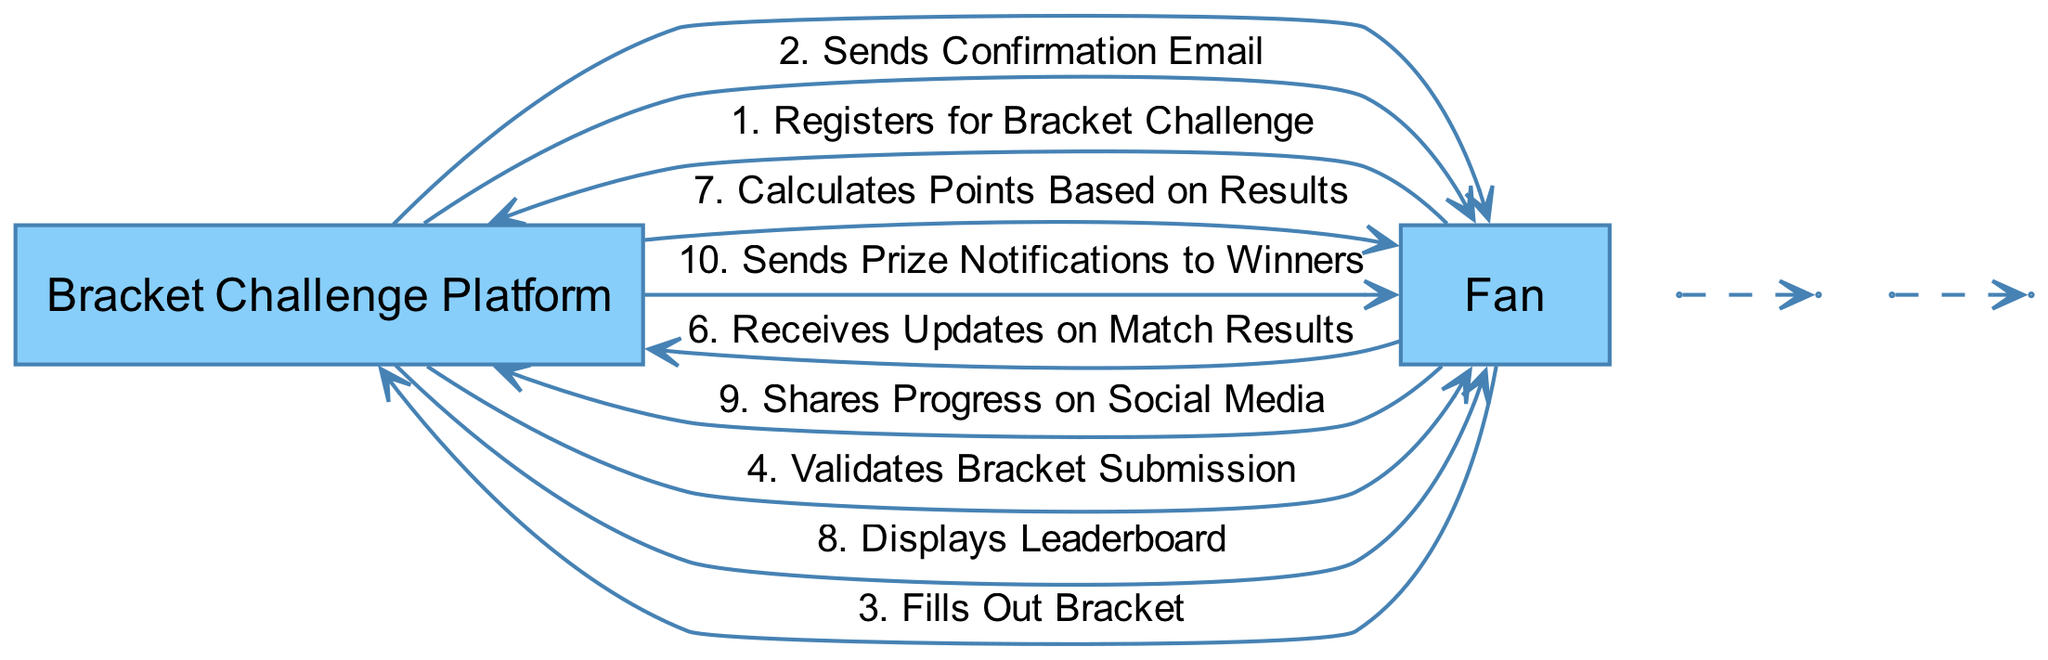What is the first action taken by the Fan? The first action taken by the Fan is 'Registers for Bracket Challenge', which is indicated as the first sequence element in the diagram.
Answer: Registers for Bracket Challenge How many total actions are represented in the diagram? There are ten sequence elements listed, which represent each action taken by either the Fan or the Bracket Challenge Platform.
Answer: Ten What follows the action 'Fills Out Bracket'? After 'Fills Out Bracket', the next action is 'Validates Bracket Submission', showing the sequence progression from the Fan filling out the bracket to the platform validating it.
Answer: Validates Bracket Submission Which actor is responsible for sending prize notifications? The 'Bracket Challenge Platform' is responsible for sending prize notifications to the winners as indicated by the last action in the sequence.
Answer: Bracket Challenge Platform What action does the Fan take after receiving updates on match results? After receiving updates on match results, the Fan 'Shares Progress on Social Media', showing their engagement and sharing their experience publicly.
Answer: Shares Progress on Social Media Identify the action that occurs immediately after 'Stores Bracket Data'. The action that occurs immediately after 'Stores Bracket Data' is 'Calculates Points Based on Results', demonstrating the flow and processing of the bracket information.
Answer: Calculates Points Based on Results What does the Bracket Challenge Platform display after calculating points? The Bracket Challenge Platform displays the 'Leaderboard' after calculating points, which ranks the participants based on their bracket performance.
Answer: Leaderboard How many actors are involved in this sequence? There are two distinct actors involved in the sequence: the Fan and the Bracket Challenge Platform, as enumerated at the beginning of the diagram.
Answer: Two What is the last action taken in the sequence? The last action taken in the sequence is 'Sends Prize Notifications to Winners', completing the process of engagement and providing closure for the challenge.
Answer: Sends Prize Notifications to Winners 